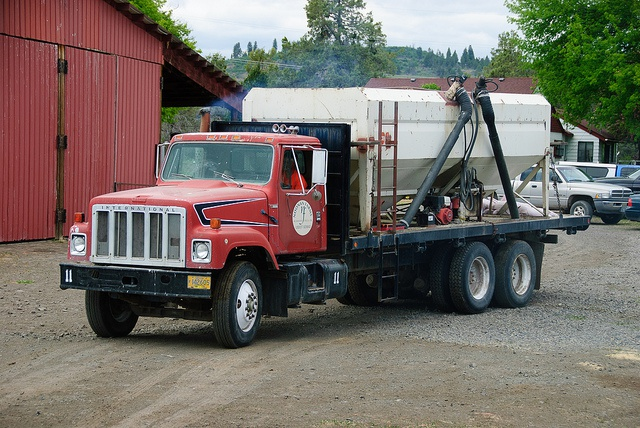Describe the objects in this image and their specific colors. I can see truck in maroon, black, lightgray, gray, and darkgray tones, truck in maroon, black, lightgray, darkgray, and gray tones, truck in maroon, white, gray, darkgray, and blue tones, truck in maroon, gray, darkgray, blue, and black tones, and car in maroon, black, blue, and darkblue tones in this image. 